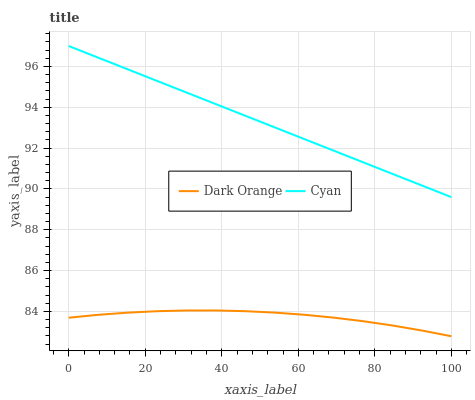Does Dark Orange have the minimum area under the curve?
Answer yes or no. Yes. Does Cyan have the maximum area under the curve?
Answer yes or no. Yes. Does Cyan have the minimum area under the curve?
Answer yes or no. No. Is Cyan the smoothest?
Answer yes or no. Yes. Is Dark Orange the roughest?
Answer yes or no. Yes. Is Cyan the roughest?
Answer yes or no. No. Does Dark Orange have the lowest value?
Answer yes or no. Yes. Does Cyan have the lowest value?
Answer yes or no. No. Does Cyan have the highest value?
Answer yes or no. Yes. Is Dark Orange less than Cyan?
Answer yes or no. Yes. Is Cyan greater than Dark Orange?
Answer yes or no. Yes. Does Dark Orange intersect Cyan?
Answer yes or no. No. 